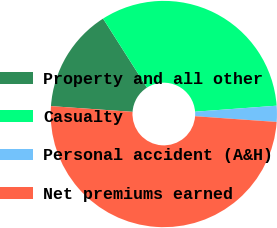Convert chart. <chart><loc_0><loc_0><loc_500><loc_500><pie_chart><fcel>Property and all other<fcel>Casualty<fcel>Personal accident (A&H)<fcel>Net premiums earned<nl><fcel>14.87%<fcel>32.85%<fcel>2.29%<fcel>50.0%<nl></chart> 